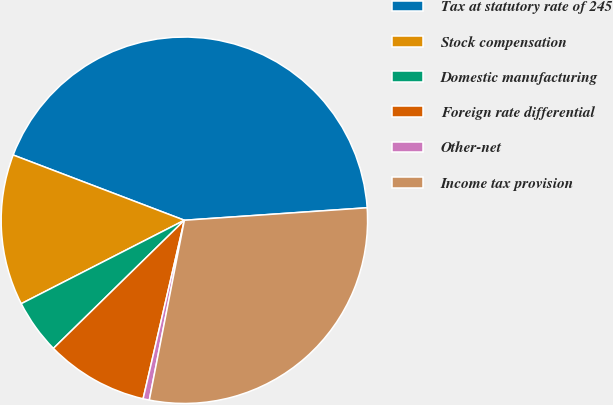Convert chart to OTSL. <chart><loc_0><loc_0><loc_500><loc_500><pie_chart><fcel>Tax at statutory rate of 245<fcel>Stock compensation<fcel>Domestic manufacturing<fcel>Foreign rate differential<fcel>Other-net<fcel>Income tax provision<nl><fcel>43.12%<fcel>13.32%<fcel>4.8%<fcel>9.06%<fcel>0.55%<fcel>29.15%<nl></chart> 